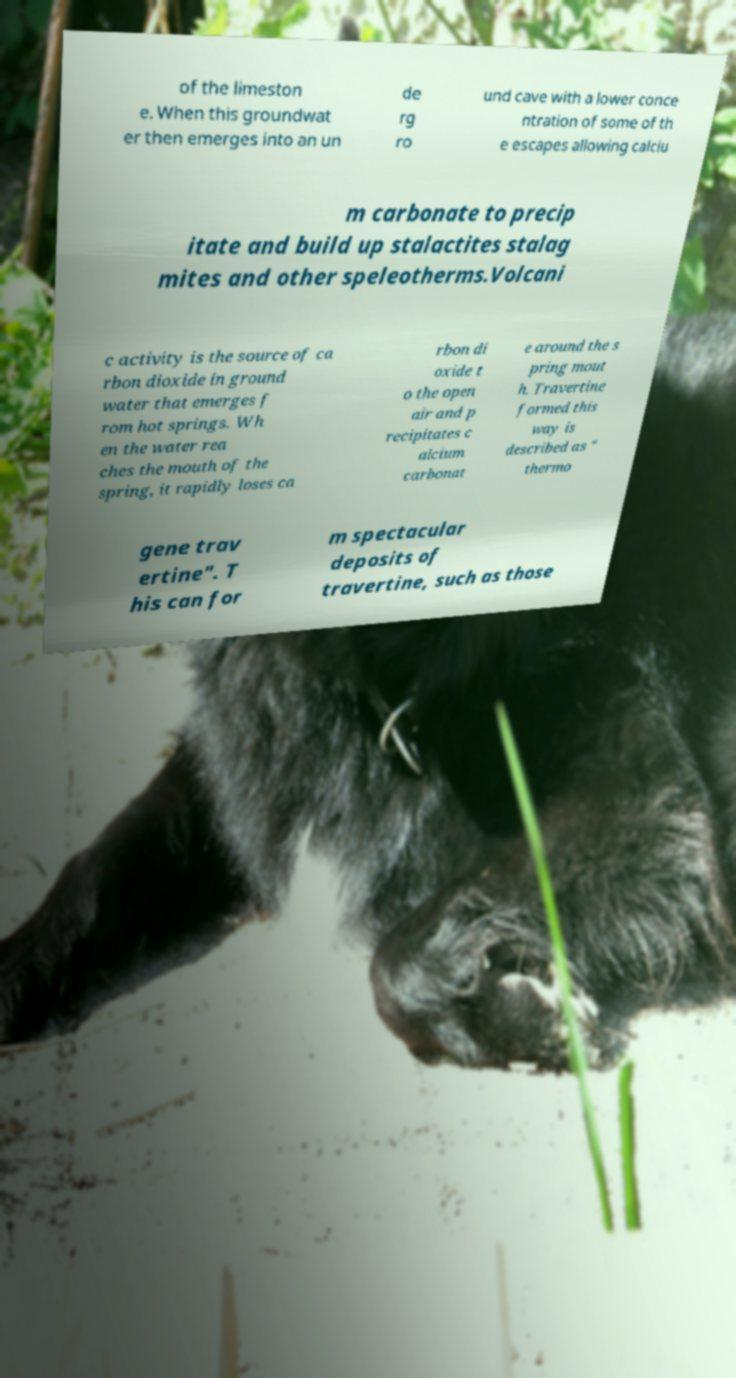What messages or text are displayed in this image? I need them in a readable, typed format. of the limeston e. When this groundwat er then emerges into an un de rg ro und cave with a lower conce ntration of some of th e escapes allowing calciu m carbonate to precip itate and build up stalactites stalag mites and other speleotherms.Volcani c activity is the source of ca rbon dioxide in ground water that emerges f rom hot springs. Wh en the water rea ches the mouth of the spring, it rapidly loses ca rbon di oxide t o the open air and p recipitates c alcium carbonat e around the s pring mout h. Travertine formed this way is described as " thermo gene trav ertine". T his can for m spectacular deposits of travertine, such as those 